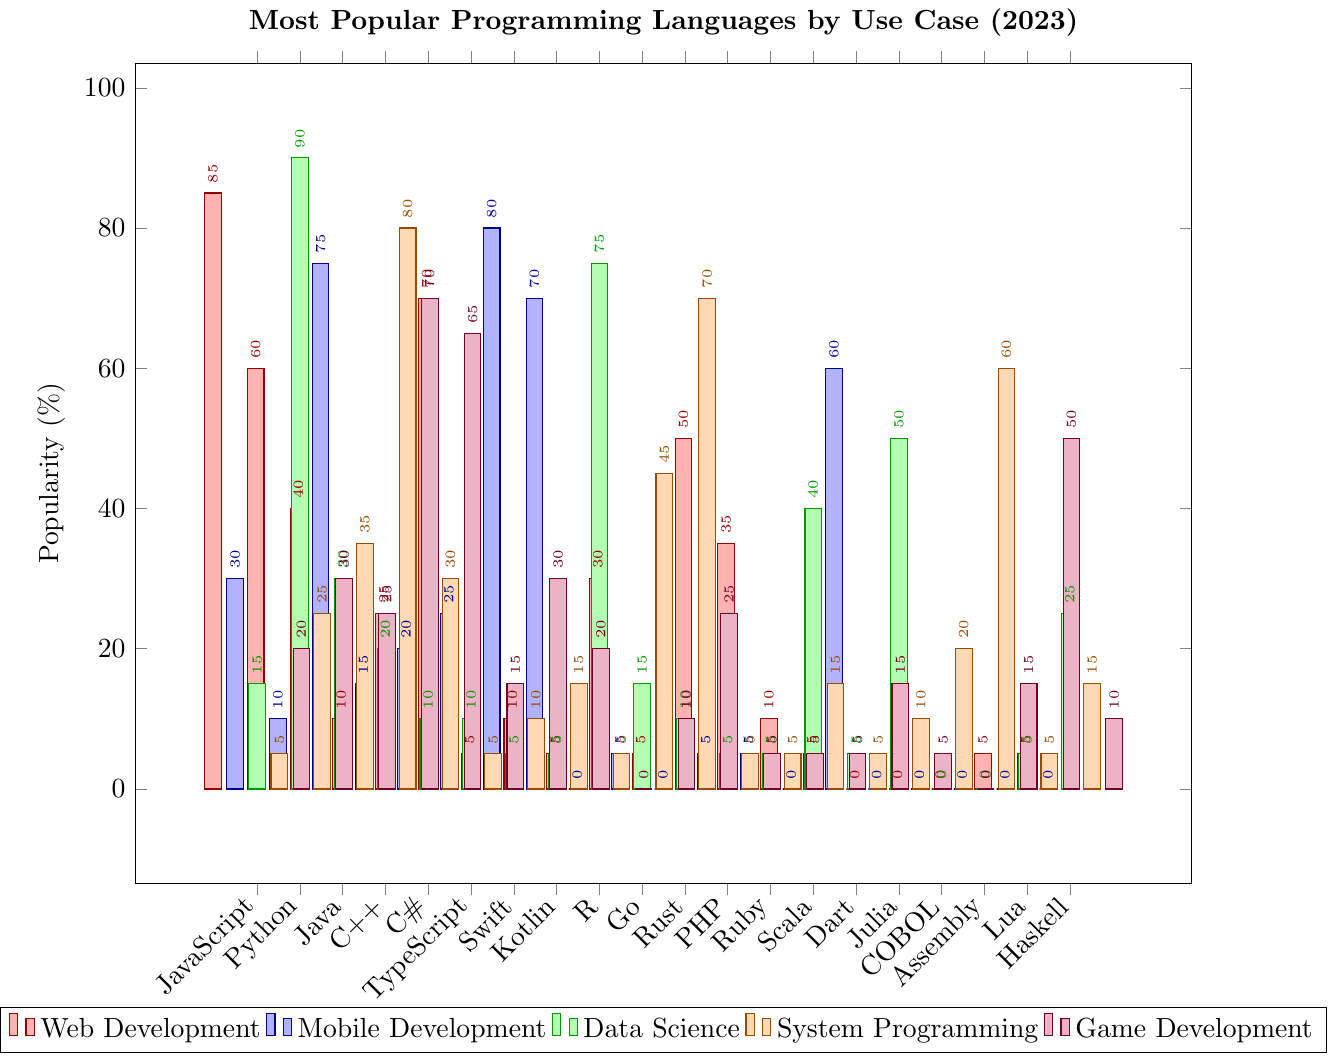What's the most popular programming language for web development? Look at the bar heights for each language under the "Web Development" category. JavaScript has the highest bar.
Answer: JavaScript Which language is more popular for mobile development, Kotlin or Swift? Compare the heights of the bars for Kotlin and Swift in the "Mobile Development" category. Swift has a higher bar than Kotlin.
Answer: Swift For system programming, how does the popularity of Rust compare to C++? Look at the bar heights for Rust and C++ under the "System Programming" category. Rust has a slightly lower bar than C++.
Answer: C++ Which language has the highest popularity for data science? Examine the "Data Science" category, the tallest bar represents Python.
Answer: Python What are the top three languages used for game development? Look at the "Game Development" category and identify the three tallest bars. C++, C#, and Lua have the highest bars.
Answer: C++, C#, Lua Which primary use case has the least variety of top programming languages? Check the number of bars that are relatively high across different categories. "Data Science" primarily highlights Python and R.
Answer: Data Science What's the combined percentage of usage for JavaScript in web development and game development? Add the percentages for JavaScript in "Web Development" (85%) and "Game Development" (20%). Sum is 85 + 20 = 105.
Answer: 105% Is Java more popular for mobile development or system programming? Compare the heights of the Java bar in "Mobile Development" and "System Programming" categories. The "Mobile Development" bar for Java is higher.
Answer: Mobile Development Which languages have the same percentage of usage (0%) in mobile development? Look at the "Mobile Development" category and identify languages with a 0% bar. R, Rust, Julia, COBOL, Assembly, Lua, and Haskell all have a 0% bar.
Answer: R, Rust, Julia, COBOL, Assembly, Lua, Haskell For web development, list languages with usage below 20%. Check the "Web Development" category and find bars with less than 20% usage. C++, Swift, Kotlin, R, Rust, Dart, Julia, COBOL, Assembly, Lua, Haskell all have less than 20%.
Answer: C++, Swift, Kotlin, R, Rust, Dart, Julia, COBOL, Assembly, Lua, Haskell 